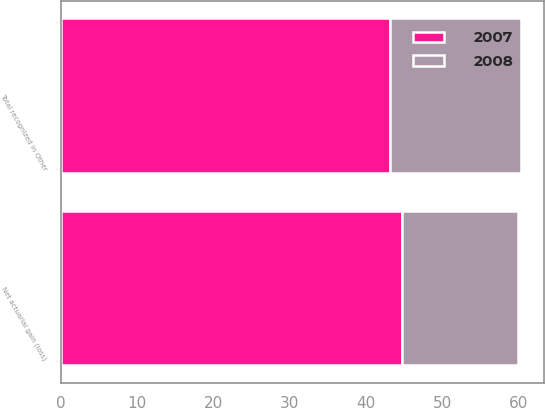Convert chart. <chart><loc_0><loc_0><loc_500><loc_500><stacked_bar_chart><ecel><fcel>Net actuarial gain (loss)<fcel>Total recognized in Other<nl><fcel>2007<fcel>44.7<fcel>43.1<nl><fcel>2008<fcel>15.2<fcel>17.3<nl></chart> 